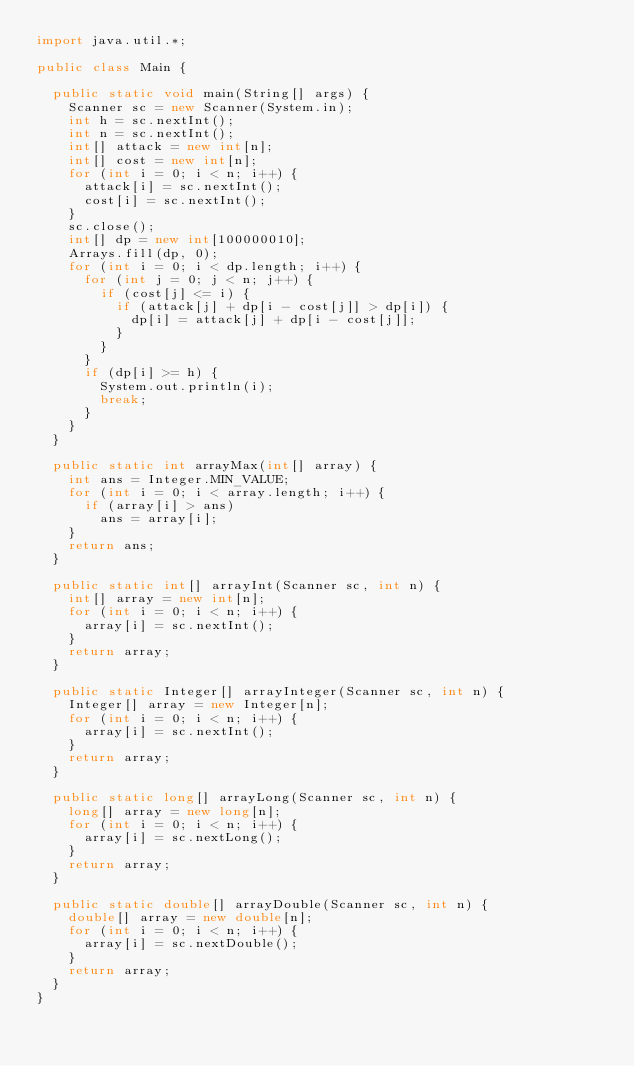<code> <loc_0><loc_0><loc_500><loc_500><_Java_>import java.util.*;

public class Main {

	public static void main(String[] args) {
		Scanner sc = new Scanner(System.in);
		int h = sc.nextInt();
		int n = sc.nextInt();
		int[] attack = new int[n];
		int[] cost = new int[n];
		for (int i = 0; i < n; i++) {
			attack[i] = sc.nextInt();
			cost[i] = sc.nextInt();
		}
		sc.close();
		int[] dp = new int[100000010];
		Arrays.fill(dp, 0);
		for (int i = 0; i < dp.length; i++) {
			for (int j = 0; j < n; j++) {
				if (cost[j] <= i) {
					if (attack[j] + dp[i - cost[j]] > dp[i]) {
						dp[i] = attack[j] + dp[i - cost[j]];
					}
				}
			}
			if (dp[i] >= h) {
				System.out.println(i);
				break;
			}
		}
	}

	public static int arrayMax(int[] array) {
		int ans = Integer.MIN_VALUE;
		for (int i = 0; i < array.length; i++) {
			if (array[i] > ans)
				ans = array[i];
		}
		return ans;
	}

	public static int[] arrayInt(Scanner sc, int n) {
		int[] array = new int[n];
		for (int i = 0; i < n; i++) {
			array[i] = sc.nextInt();
		}
		return array;
	}

	public static Integer[] arrayInteger(Scanner sc, int n) {
		Integer[] array = new Integer[n];
		for (int i = 0; i < n; i++) {
			array[i] = sc.nextInt();
		}
		return array;
	}

	public static long[] arrayLong(Scanner sc, int n) {
		long[] array = new long[n];
		for (int i = 0; i < n; i++) {
			array[i] = sc.nextLong();
		}
		return array;
	}

	public static double[] arrayDouble(Scanner sc, int n) {
		double[] array = new double[n];
		for (int i = 0; i < n; i++) {
			array[i] = sc.nextDouble();
		}
		return array;
	}
}</code> 